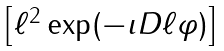Convert formula to latex. <formula><loc_0><loc_0><loc_500><loc_500>\begin{bmatrix} \ell ^ { 2 } \exp ( - \imath D \ell \varphi ) \end{bmatrix}</formula> 